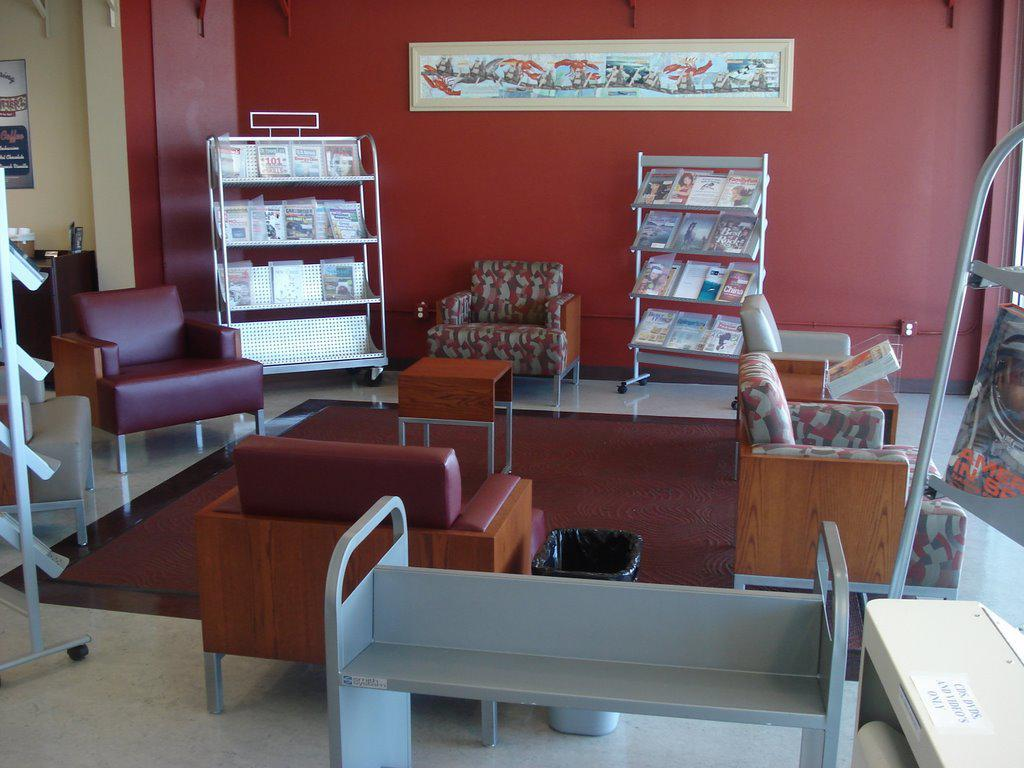What type of furniture is present in the image? There are sofa chairs in the image. What can be seen on the shelves or racks in the image? There are books in the racks in the image. What decorative item is hanging on the wall in the image? There is a painting on the wall in the image. What type of locket can be seen hanging from the sofa chair in the image? There is no locket present on the sofa chair in the image. 